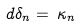<formula> <loc_0><loc_0><loc_500><loc_500>d \delta _ { n } = \, \kappa _ { n }</formula> 